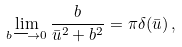Convert formula to latex. <formula><loc_0><loc_0><loc_500><loc_500>\lim _ { b \longrightarrow 0 } \frac { b } { \bar { u } ^ { 2 } + b ^ { 2 } } = \pi \delta ( \bar { u } ) \, ,</formula> 